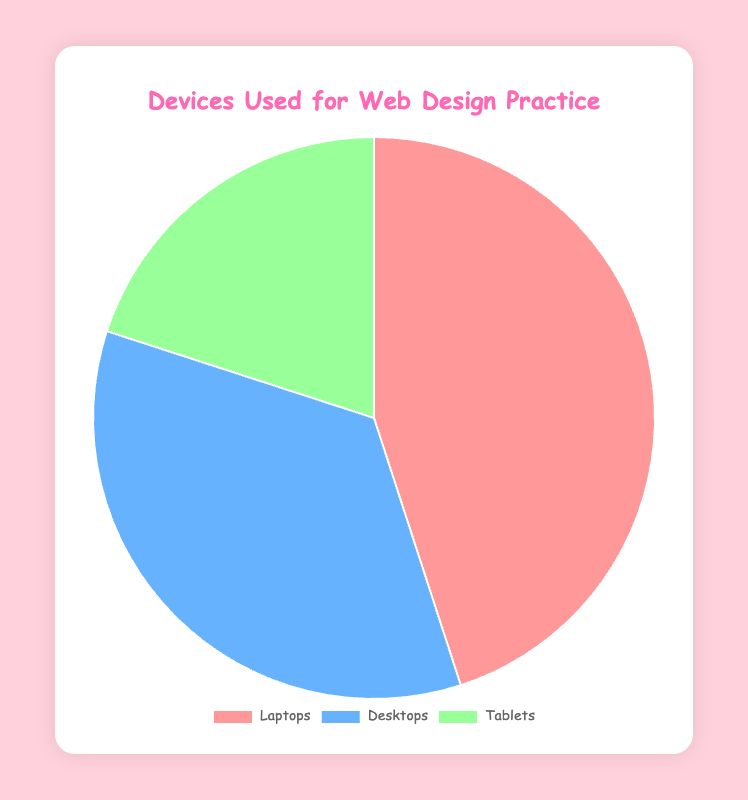What percentage of devices used are Laptops? To find the percentage for Laptops, simply look at the value associated with 'Laptops' in the chart which is 45%.
Answer: 45% Which device is the least used for web design practice? By comparing the percentages, the device with the smallest percentage is Tablets with 20%.
Answer: Tablets What is the combined percentage of Laptops and Desktops used for web design practice? Combine the percentages of Laptops and Desktops: 45% (Laptops) + 35% (Desktops) = 80%.
Answer: 80% How much more are Laptops used compared to Tablets? Subtract the percentage of Tablets from the percentage of Laptops: 45% (Laptops) - 20% (Tablets) = 25%.
Answer: 25% Which device category uses green in the pie chart? The pie chart's color scheme indicates that Tablets use green (based on the color description).
Answer: Tablets What is the ratio of Laptops to Desktops used for web design practice? Divide the percentage of Laptops by the percentage of Desktops: 45% / 35% = 1.29 (approximately).
Answer: 1.29 Which device's percentage is closest to the average percentage of all devices? Calculate the average percentage: (45% + 35% + 20%) / 3 = 33.33%. The percentage closest to 33.33% is Desktops with 35%.
Answer: Desktops If the percentage of Tablet usage increased by 10 percentage points, what would be the new percentage of Tablets? Add 10 percentage points to the current percentage of Tablets: 20% + 10% = 30%.
Answer: 30% What is the difference in usage percentage between the most used and least used devices? Find the difference between the highest and lowest percentages: 45% (Laptops) - 20% (Tablets) = 25%.
Answer: 25% Which device's usage percentage is depicted using blue color in the pie chart? The pie chart shows Desktops using blue color.
Answer: Desktops 